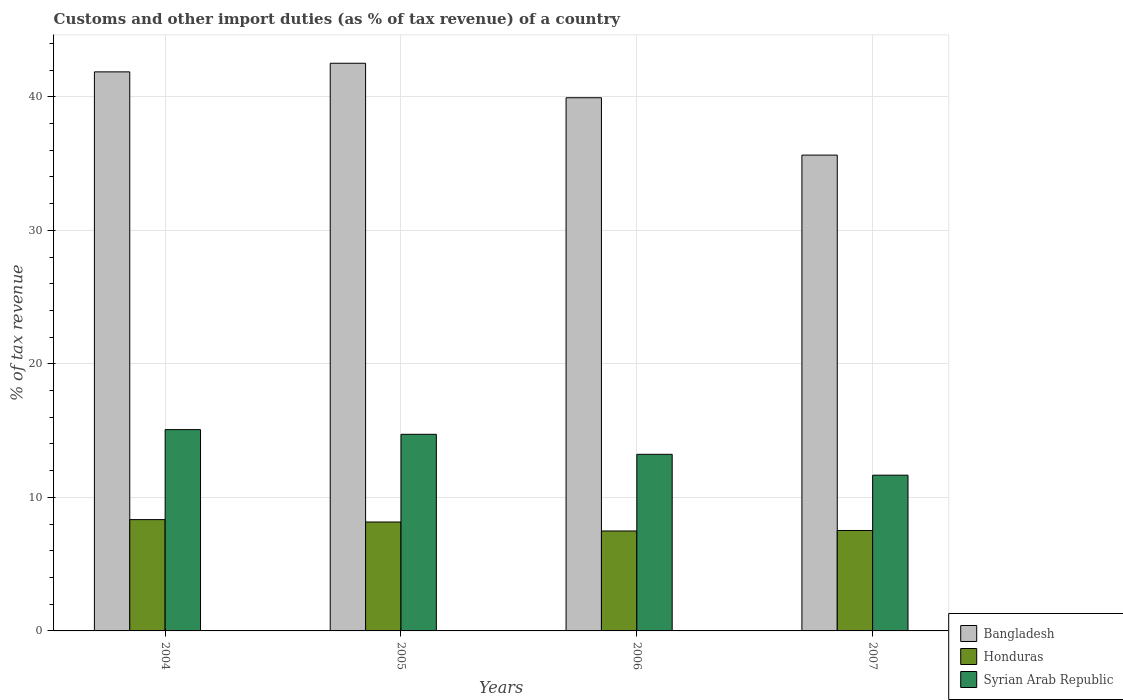Are the number of bars on each tick of the X-axis equal?
Keep it short and to the point. Yes. What is the label of the 2nd group of bars from the left?
Your answer should be compact. 2005. In how many cases, is the number of bars for a given year not equal to the number of legend labels?
Give a very brief answer. 0. What is the percentage of tax revenue from customs in Honduras in 2006?
Your answer should be compact. 7.48. Across all years, what is the maximum percentage of tax revenue from customs in Bangladesh?
Make the answer very short. 42.51. Across all years, what is the minimum percentage of tax revenue from customs in Bangladesh?
Ensure brevity in your answer.  35.63. In which year was the percentage of tax revenue from customs in Bangladesh maximum?
Your answer should be compact. 2005. In which year was the percentage of tax revenue from customs in Honduras minimum?
Keep it short and to the point. 2006. What is the total percentage of tax revenue from customs in Bangladesh in the graph?
Offer a terse response. 159.94. What is the difference between the percentage of tax revenue from customs in Syrian Arab Republic in 2006 and that in 2007?
Make the answer very short. 1.56. What is the difference between the percentage of tax revenue from customs in Honduras in 2005 and the percentage of tax revenue from customs in Syrian Arab Republic in 2004?
Keep it short and to the point. -6.92. What is the average percentage of tax revenue from customs in Syrian Arab Republic per year?
Offer a very short reply. 13.67. In the year 2007, what is the difference between the percentage of tax revenue from customs in Honduras and percentage of tax revenue from customs in Syrian Arab Republic?
Ensure brevity in your answer.  -4.14. What is the ratio of the percentage of tax revenue from customs in Honduras in 2005 to that in 2006?
Your answer should be compact. 1.09. Is the percentage of tax revenue from customs in Honduras in 2004 less than that in 2006?
Keep it short and to the point. No. What is the difference between the highest and the second highest percentage of tax revenue from customs in Bangladesh?
Offer a very short reply. 0.64. What is the difference between the highest and the lowest percentage of tax revenue from customs in Syrian Arab Republic?
Your answer should be very brief. 3.41. What does the 1st bar from the left in 2004 represents?
Your response must be concise. Bangladesh. What does the 2nd bar from the right in 2007 represents?
Keep it short and to the point. Honduras. How many bars are there?
Make the answer very short. 12. Does the graph contain grids?
Your answer should be compact. Yes. How many legend labels are there?
Ensure brevity in your answer.  3. How are the legend labels stacked?
Make the answer very short. Vertical. What is the title of the graph?
Offer a very short reply. Customs and other import duties (as % of tax revenue) of a country. Does "Greece" appear as one of the legend labels in the graph?
Your answer should be compact. No. What is the label or title of the X-axis?
Ensure brevity in your answer.  Years. What is the label or title of the Y-axis?
Ensure brevity in your answer.  % of tax revenue. What is the % of tax revenue in Bangladesh in 2004?
Give a very brief answer. 41.87. What is the % of tax revenue of Honduras in 2004?
Keep it short and to the point. 8.34. What is the % of tax revenue of Syrian Arab Republic in 2004?
Provide a succinct answer. 15.08. What is the % of tax revenue of Bangladesh in 2005?
Your answer should be compact. 42.51. What is the % of tax revenue in Honduras in 2005?
Ensure brevity in your answer.  8.16. What is the % of tax revenue in Syrian Arab Republic in 2005?
Your response must be concise. 14.72. What is the % of tax revenue in Bangladesh in 2006?
Offer a very short reply. 39.93. What is the % of tax revenue of Honduras in 2006?
Provide a short and direct response. 7.48. What is the % of tax revenue in Syrian Arab Republic in 2006?
Your answer should be compact. 13.22. What is the % of tax revenue of Bangladesh in 2007?
Provide a succinct answer. 35.63. What is the % of tax revenue in Honduras in 2007?
Provide a short and direct response. 7.52. What is the % of tax revenue in Syrian Arab Republic in 2007?
Ensure brevity in your answer.  11.66. Across all years, what is the maximum % of tax revenue of Bangladesh?
Ensure brevity in your answer.  42.51. Across all years, what is the maximum % of tax revenue in Honduras?
Ensure brevity in your answer.  8.34. Across all years, what is the maximum % of tax revenue of Syrian Arab Republic?
Provide a short and direct response. 15.08. Across all years, what is the minimum % of tax revenue of Bangladesh?
Offer a terse response. 35.63. Across all years, what is the minimum % of tax revenue of Honduras?
Provide a short and direct response. 7.48. Across all years, what is the minimum % of tax revenue of Syrian Arab Republic?
Your answer should be very brief. 11.66. What is the total % of tax revenue in Bangladesh in the graph?
Make the answer very short. 159.94. What is the total % of tax revenue of Honduras in the graph?
Make the answer very short. 31.5. What is the total % of tax revenue of Syrian Arab Republic in the graph?
Provide a short and direct response. 54.69. What is the difference between the % of tax revenue in Bangladesh in 2004 and that in 2005?
Offer a very short reply. -0.64. What is the difference between the % of tax revenue in Honduras in 2004 and that in 2005?
Offer a terse response. 0.18. What is the difference between the % of tax revenue in Syrian Arab Republic in 2004 and that in 2005?
Provide a short and direct response. 0.35. What is the difference between the % of tax revenue of Bangladesh in 2004 and that in 2006?
Ensure brevity in your answer.  1.94. What is the difference between the % of tax revenue of Honduras in 2004 and that in 2006?
Offer a terse response. 0.85. What is the difference between the % of tax revenue in Syrian Arab Republic in 2004 and that in 2006?
Your answer should be compact. 1.85. What is the difference between the % of tax revenue in Bangladesh in 2004 and that in 2007?
Offer a very short reply. 6.23. What is the difference between the % of tax revenue of Honduras in 2004 and that in 2007?
Offer a very short reply. 0.81. What is the difference between the % of tax revenue of Syrian Arab Republic in 2004 and that in 2007?
Provide a short and direct response. 3.41. What is the difference between the % of tax revenue of Bangladesh in 2005 and that in 2006?
Provide a succinct answer. 2.58. What is the difference between the % of tax revenue of Honduras in 2005 and that in 2006?
Ensure brevity in your answer.  0.67. What is the difference between the % of tax revenue of Syrian Arab Republic in 2005 and that in 2006?
Offer a very short reply. 1.5. What is the difference between the % of tax revenue of Bangladesh in 2005 and that in 2007?
Provide a succinct answer. 6.88. What is the difference between the % of tax revenue of Honduras in 2005 and that in 2007?
Provide a short and direct response. 0.63. What is the difference between the % of tax revenue of Syrian Arab Republic in 2005 and that in 2007?
Provide a short and direct response. 3.06. What is the difference between the % of tax revenue in Bangladesh in 2006 and that in 2007?
Your answer should be very brief. 4.3. What is the difference between the % of tax revenue in Honduras in 2006 and that in 2007?
Give a very brief answer. -0.04. What is the difference between the % of tax revenue in Syrian Arab Republic in 2006 and that in 2007?
Ensure brevity in your answer.  1.56. What is the difference between the % of tax revenue of Bangladesh in 2004 and the % of tax revenue of Honduras in 2005?
Offer a very short reply. 33.71. What is the difference between the % of tax revenue of Bangladesh in 2004 and the % of tax revenue of Syrian Arab Republic in 2005?
Keep it short and to the point. 27.14. What is the difference between the % of tax revenue of Honduras in 2004 and the % of tax revenue of Syrian Arab Republic in 2005?
Offer a terse response. -6.39. What is the difference between the % of tax revenue of Bangladesh in 2004 and the % of tax revenue of Honduras in 2006?
Provide a succinct answer. 34.38. What is the difference between the % of tax revenue in Bangladesh in 2004 and the % of tax revenue in Syrian Arab Republic in 2006?
Make the answer very short. 28.64. What is the difference between the % of tax revenue of Honduras in 2004 and the % of tax revenue of Syrian Arab Republic in 2006?
Your response must be concise. -4.89. What is the difference between the % of tax revenue of Bangladesh in 2004 and the % of tax revenue of Honduras in 2007?
Make the answer very short. 34.34. What is the difference between the % of tax revenue of Bangladesh in 2004 and the % of tax revenue of Syrian Arab Republic in 2007?
Keep it short and to the point. 30.2. What is the difference between the % of tax revenue of Honduras in 2004 and the % of tax revenue of Syrian Arab Republic in 2007?
Offer a very short reply. -3.33. What is the difference between the % of tax revenue in Bangladesh in 2005 and the % of tax revenue in Honduras in 2006?
Provide a succinct answer. 35.03. What is the difference between the % of tax revenue of Bangladesh in 2005 and the % of tax revenue of Syrian Arab Republic in 2006?
Provide a short and direct response. 29.29. What is the difference between the % of tax revenue in Honduras in 2005 and the % of tax revenue in Syrian Arab Republic in 2006?
Provide a short and direct response. -5.07. What is the difference between the % of tax revenue in Bangladesh in 2005 and the % of tax revenue in Honduras in 2007?
Your answer should be compact. 34.99. What is the difference between the % of tax revenue in Bangladesh in 2005 and the % of tax revenue in Syrian Arab Republic in 2007?
Provide a succinct answer. 30.85. What is the difference between the % of tax revenue of Honduras in 2005 and the % of tax revenue of Syrian Arab Republic in 2007?
Your response must be concise. -3.51. What is the difference between the % of tax revenue in Bangladesh in 2006 and the % of tax revenue in Honduras in 2007?
Ensure brevity in your answer.  32.41. What is the difference between the % of tax revenue of Bangladesh in 2006 and the % of tax revenue of Syrian Arab Republic in 2007?
Provide a short and direct response. 28.27. What is the difference between the % of tax revenue in Honduras in 2006 and the % of tax revenue in Syrian Arab Republic in 2007?
Your answer should be compact. -4.18. What is the average % of tax revenue of Bangladesh per year?
Your answer should be very brief. 39.99. What is the average % of tax revenue of Honduras per year?
Your answer should be compact. 7.88. What is the average % of tax revenue of Syrian Arab Republic per year?
Provide a short and direct response. 13.67. In the year 2004, what is the difference between the % of tax revenue in Bangladesh and % of tax revenue in Honduras?
Provide a short and direct response. 33.53. In the year 2004, what is the difference between the % of tax revenue in Bangladesh and % of tax revenue in Syrian Arab Republic?
Your answer should be compact. 26.79. In the year 2004, what is the difference between the % of tax revenue of Honduras and % of tax revenue of Syrian Arab Republic?
Your answer should be compact. -6.74. In the year 2005, what is the difference between the % of tax revenue in Bangladesh and % of tax revenue in Honduras?
Make the answer very short. 34.36. In the year 2005, what is the difference between the % of tax revenue of Bangladesh and % of tax revenue of Syrian Arab Republic?
Your response must be concise. 27.79. In the year 2005, what is the difference between the % of tax revenue of Honduras and % of tax revenue of Syrian Arab Republic?
Ensure brevity in your answer.  -6.57. In the year 2006, what is the difference between the % of tax revenue of Bangladesh and % of tax revenue of Honduras?
Keep it short and to the point. 32.44. In the year 2006, what is the difference between the % of tax revenue of Bangladesh and % of tax revenue of Syrian Arab Republic?
Ensure brevity in your answer.  26.7. In the year 2006, what is the difference between the % of tax revenue of Honduras and % of tax revenue of Syrian Arab Republic?
Offer a very short reply. -5.74. In the year 2007, what is the difference between the % of tax revenue in Bangladesh and % of tax revenue in Honduras?
Keep it short and to the point. 28.11. In the year 2007, what is the difference between the % of tax revenue of Bangladesh and % of tax revenue of Syrian Arab Republic?
Provide a succinct answer. 23.97. In the year 2007, what is the difference between the % of tax revenue of Honduras and % of tax revenue of Syrian Arab Republic?
Give a very brief answer. -4.14. What is the ratio of the % of tax revenue of Syrian Arab Republic in 2004 to that in 2005?
Your response must be concise. 1.02. What is the ratio of the % of tax revenue of Bangladesh in 2004 to that in 2006?
Make the answer very short. 1.05. What is the ratio of the % of tax revenue in Honduras in 2004 to that in 2006?
Offer a terse response. 1.11. What is the ratio of the % of tax revenue in Syrian Arab Republic in 2004 to that in 2006?
Make the answer very short. 1.14. What is the ratio of the % of tax revenue of Bangladesh in 2004 to that in 2007?
Keep it short and to the point. 1.17. What is the ratio of the % of tax revenue in Honduras in 2004 to that in 2007?
Your answer should be compact. 1.11. What is the ratio of the % of tax revenue of Syrian Arab Republic in 2004 to that in 2007?
Give a very brief answer. 1.29. What is the ratio of the % of tax revenue in Bangladesh in 2005 to that in 2006?
Ensure brevity in your answer.  1.06. What is the ratio of the % of tax revenue of Honduras in 2005 to that in 2006?
Your answer should be very brief. 1.09. What is the ratio of the % of tax revenue in Syrian Arab Republic in 2005 to that in 2006?
Your response must be concise. 1.11. What is the ratio of the % of tax revenue in Bangladesh in 2005 to that in 2007?
Give a very brief answer. 1.19. What is the ratio of the % of tax revenue in Honduras in 2005 to that in 2007?
Offer a terse response. 1.08. What is the ratio of the % of tax revenue of Syrian Arab Republic in 2005 to that in 2007?
Keep it short and to the point. 1.26. What is the ratio of the % of tax revenue of Bangladesh in 2006 to that in 2007?
Make the answer very short. 1.12. What is the ratio of the % of tax revenue of Syrian Arab Republic in 2006 to that in 2007?
Your answer should be compact. 1.13. What is the difference between the highest and the second highest % of tax revenue in Bangladesh?
Your answer should be very brief. 0.64. What is the difference between the highest and the second highest % of tax revenue in Honduras?
Keep it short and to the point. 0.18. What is the difference between the highest and the second highest % of tax revenue in Syrian Arab Republic?
Offer a very short reply. 0.35. What is the difference between the highest and the lowest % of tax revenue in Bangladesh?
Ensure brevity in your answer.  6.88. What is the difference between the highest and the lowest % of tax revenue in Honduras?
Your response must be concise. 0.85. What is the difference between the highest and the lowest % of tax revenue of Syrian Arab Republic?
Provide a succinct answer. 3.41. 